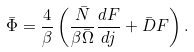<formula> <loc_0><loc_0><loc_500><loc_500>\bar { \Phi } = \frac { 4 } { \beta } \left ( \frac { { \bar { N } } } { \beta \bar { \Omega } } \frac { d F } { d j } + { \bar { D } } F \right ) .</formula> 